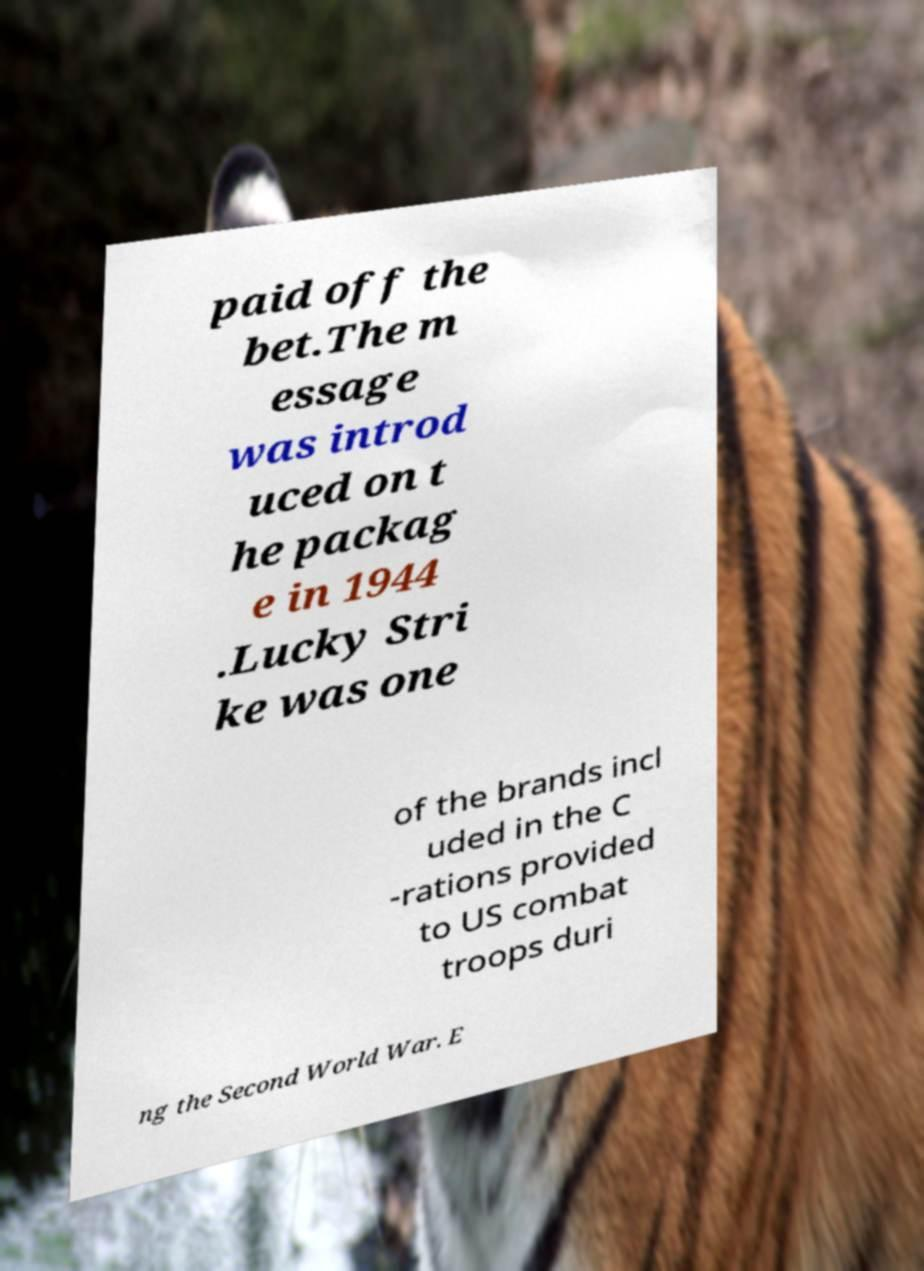Please read and relay the text visible in this image. What does it say? paid off the bet.The m essage was introd uced on t he packag e in 1944 .Lucky Stri ke was one of the brands incl uded in the C -rations provided to US combat troops duri ng the Second World War. E 